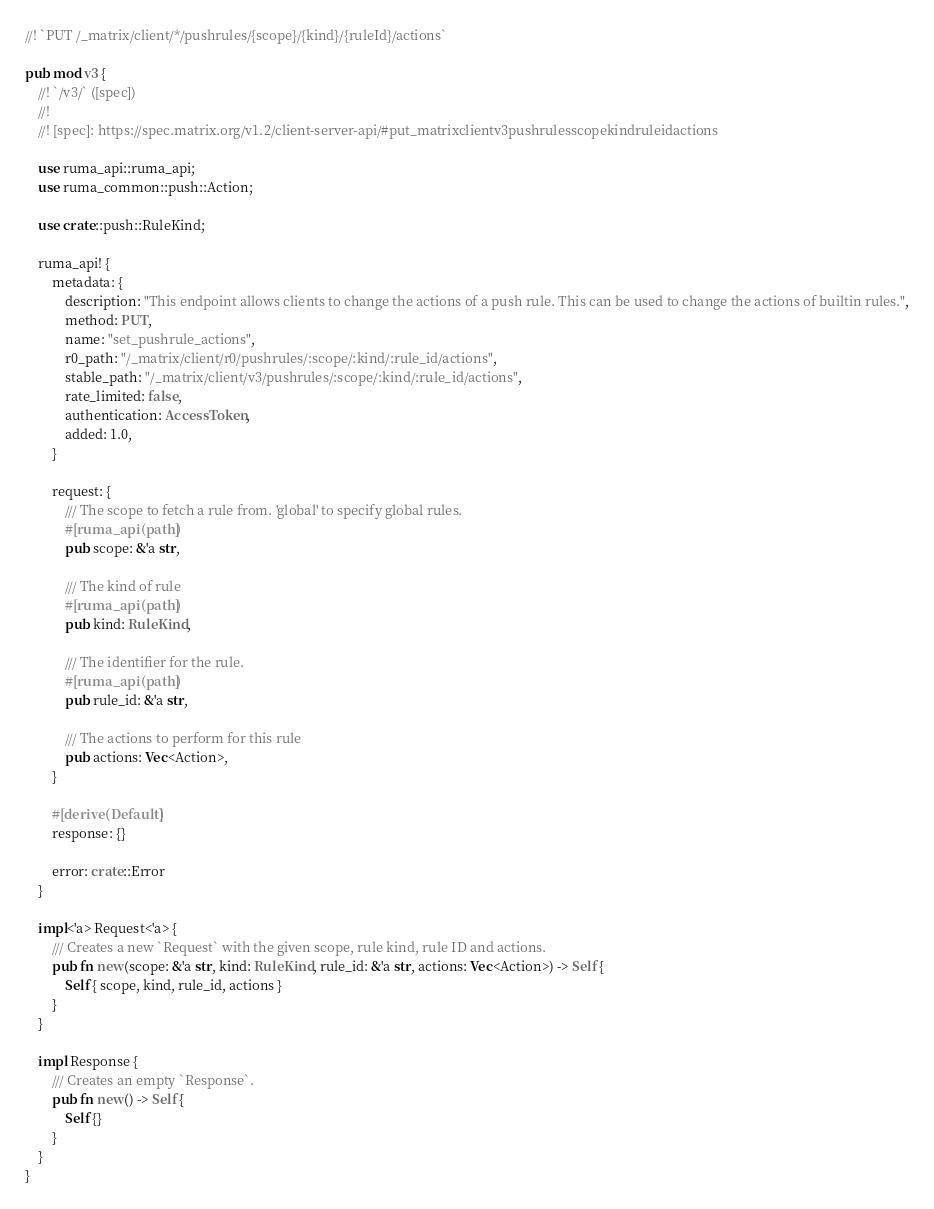Convert code to text. <code><loc_0><loc_0><loc_500><loc_500><_Rust_>//! `PUT /_matrix/client/*/pushrules/{scope}/{kind}/{ruleId}/actions`

pub mod v3 {
    //! `/v3/` ([spec])
    //!
    //! [spec]: https://spec.matrix.org/v1.2/client-server-api/#put_matrixclientv3pushrulesscopekindruleidactions

    use ruma_api::ruma_api;
    use ruma_common::push::Action;

    use crate::push::RuleKind;

    ruma_api! {
        metadata: {
            description: "This endpoint allows clients to change the actions of a push rule. This can be used to change the actions of builtin rules.",
            method: PUT,
            name: "set_pushrule_actions",
            r0_path: "/_matrix/client/r0/pushrules/:scope/:kind/:rule_id/actions",
            stable_path: "/_matrix/client/v3/pushrules/:scope/:kind/:rule_id/actions",
            rate_limited: false,
            authentication: AccessToken,
            added: 1.0,
        }

        request: {
            /// The scope to fetch a rule from. 'global' to specify global rules.
            #[ruma_api(path)]
            pub scope: &'a str,

            /// The kind of rule
            #[ruma_api(path)]
            pub kind: RuleKind,

            /// The identifier for the rule.
            #[ruma_api(path)]
            pub rule_id: &'a str,

            /// The actions to perform for this rule
            pub actions: Vec<Action>,
        }

        #[derive(Default)]
        response: {}

        error: crate::Error
    }

    impl<'a> Request<'a> {
        /// Creates a new `Request` with the given scope, rule kind, rule ID and actions.
        pub fn new(scope: &'a str, kind: RuleKind, rule_id: &'a str, actions: Vec<Action>) -> Self {
            Self { scope, kind, rule_id, actions }
        }
    }

    impl Response {
        /// Creates an empty `Response`.
        pub fn new() -> Self {
            Self {}
        }
    }
}
</code> 